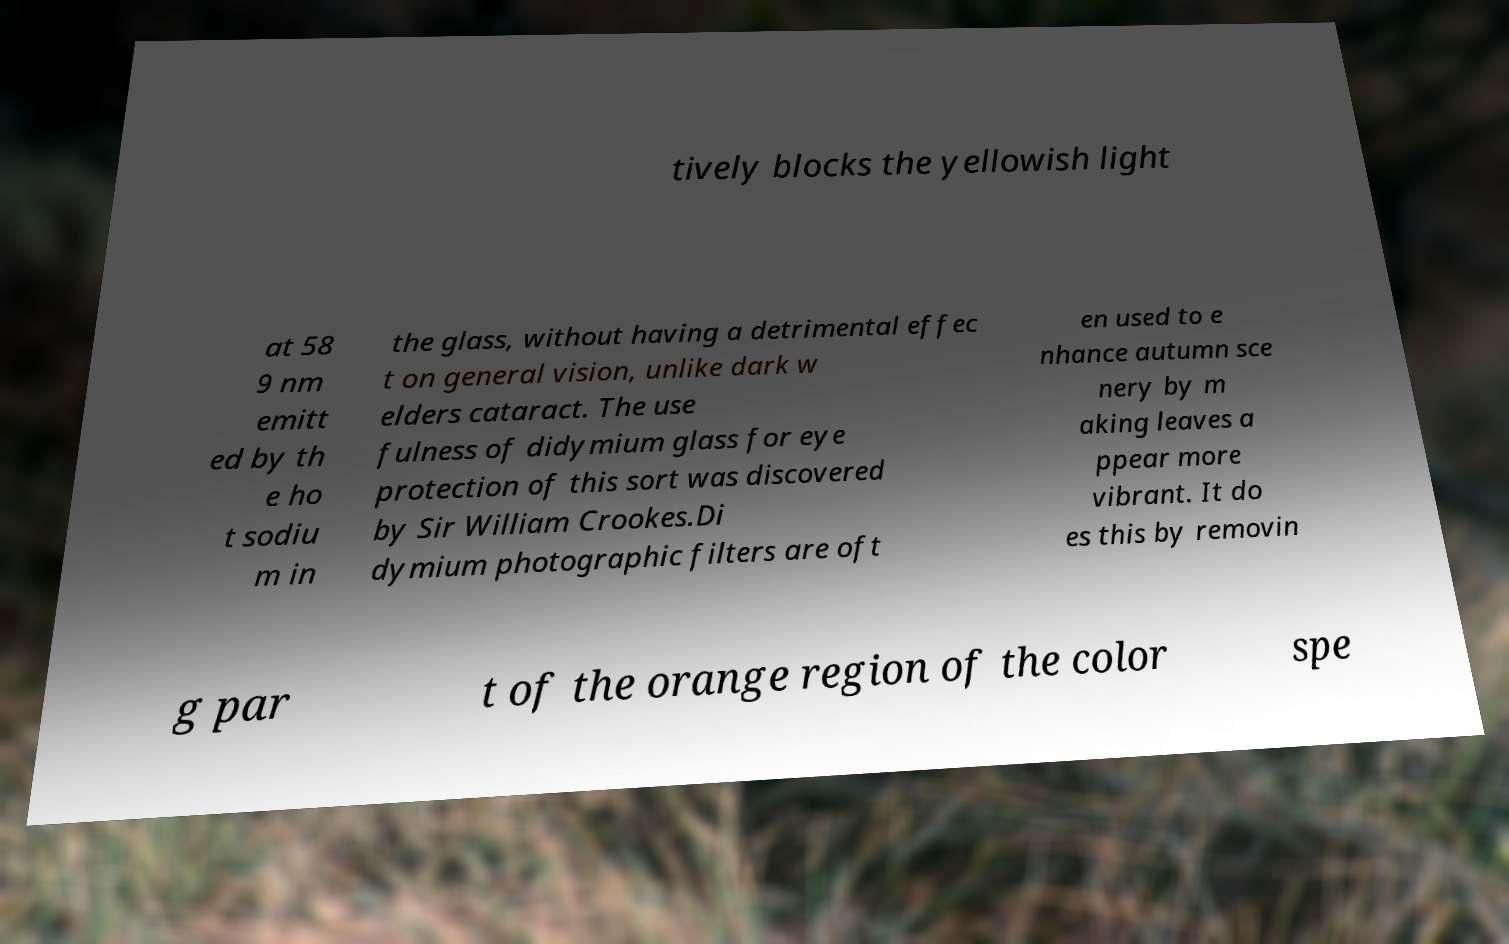Can you read and provide the text displayed in the image?This photo seems to have some interesting text. Can you extract and type it out for me? tively blocks the yellowish light at 58 9 nm emitt ed by th e ho t sodiu m in the glass, without having a detrimental effec t on general vision, unlike dark w elders cataract. The use fulness of didymium glass for eye protection of this sort was discovered by Sir William Crookes.Di dymium photographic filters are oft en used to e nhance autumn sce nery by m aking leaves a ppear more vibrant. It do es this by removin g par t of the orange region of the color spe 